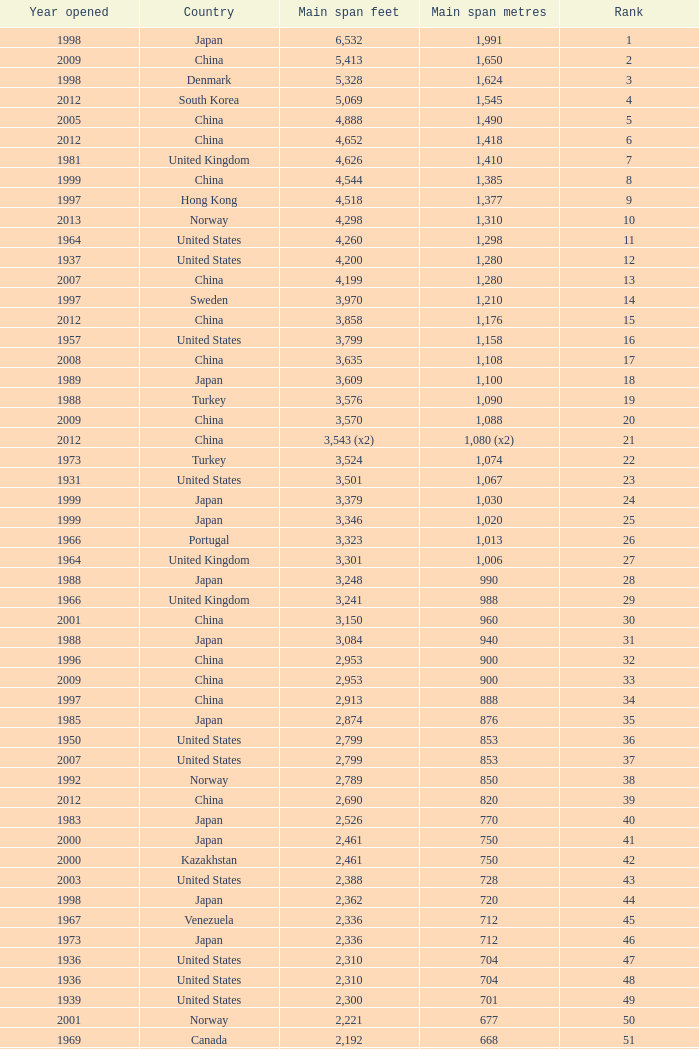What is the main span in feet from a year of 2009 or more recent with a rank less than 94 and 1,310 main span metres? 4298.0. 